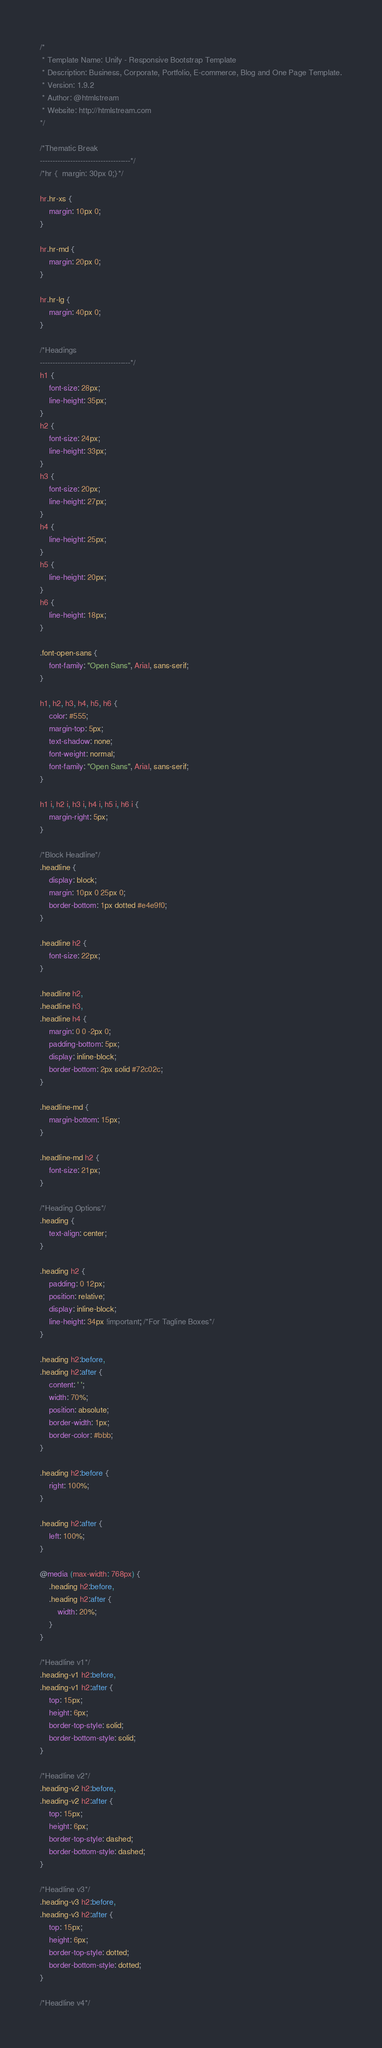<code> <loc_0><loc_0><loc_500><loc_500><_CSS_>/*
 * Template Name: Unify - Responsive Bootstrap Template
 * Description: Business, Corporate, Portfolio, E-commerce, Blog and One Page Template.
 * Version: 1.9.2
 * Author: @htmlstream
 * Website: http://htmlstream.com
*/

/*Thematic Break
------------------------------------*/
/*hr {	margin: 30px 0;}*/

hr.hr-xs {
	margin: 10px 0;
}

hr.hr-md {
	margin: 20px 0;
}

hr.hr-lg {
	margin: 40px 0;
}

/*Headings
------------------------------------*/
h1 {
	font-size: 28px;
	line-height: 35px;
}
h2 {
	font-size: 24px;
	line-height: 33px;
}
h3 {
	font-size: 20px;
	line-height: 27px;
}
h4 {
	line-height: 25px;
}
h5 {
	line-height: 20px;
}
h6 {
	line-height: 18px;
}

.font-open-sans {
	font-family: "Open Sans", Arial, sans-serif;
}

h1, h2, h3, h4, h5, h6 {
	color: #555;
	margin-top: 5px;
	text-shadow: none;
	font-weight: normal;
	font-family: "Open Sans", Arial, sans-serif;
}

h1 i, h2 i, h3 i, h4 i, h5 i, h6 i {
	margin-right: 5px;
}

/*Block Headline*/
.headline {
	display: block;
	margin: 10px 0 25px 0;
	border-bottom: 1px dotted #e4e9f0;
}

.headline h2 {
	font-size: 22px;
}

.headline h2,
.headline h3,
.headline h4 {
	margin: 0 0 -2px 0;
	padding-bottom: 5px;
	display: inline-block;
	border-bottom: 2px solid #72c02c;
}

.headline-md {
	margin-bottom: 15px;
}

.headline-md h2 {
	font-size: 21px;
}

/*Heading Options*/
.heading {
	text-align: center;
}

.heading h2 {
	padding: 0 12px;
	position: relative;
	display: inline-block;
	line-height: 34px !important; /*For Tagline Boxes*/
}

.heading h2:before,
.heading h2:after {
	content: ' ';
	width: 70%;
	position: absolute;
	border-width: 1px;
	border-color: #bbb;
}

.heading h2:before {
	right: 100%;
}

.heading h2:after {
	left: 100%;
}

@media (max-width: 768px) {
	.heading h2:before,
	.heading h2:after {
		width: 20%;
	}
}

/*Headline v1*/
.heading-v1 h2:before,
.heading-v1 h2:after {
	top: 15px;
	height: 6px;
	border-top-style: solid;
	border-bottom-style: solid;
}

/*Headline v2*/
.heading-v2 h2:before,
.heading-v2 h2:after {
	top: 15px;
	height: 6px;
	border-top-style: dashed;
	border-bottom-style: dashed;
}

/*Headline v3*/
.heading-v3 h2:before,
.heading-v3 h2:after {
	top: 15px;
	height: 6px;
	border-top-style: dotted;
	border-bottom-style: dotted;
}

/*Headline v4*/</code> 